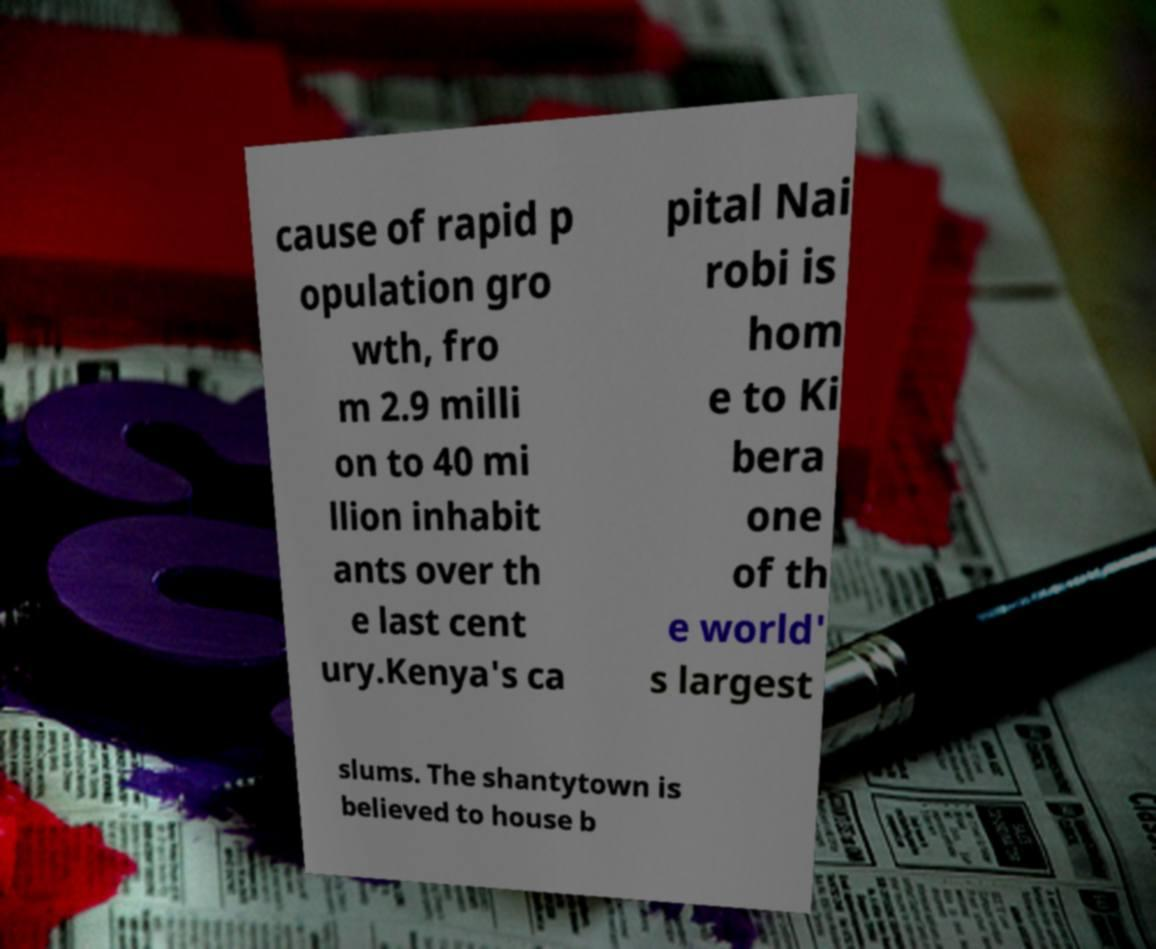For documentation purposes, I need the text within this image transcribed. Could you provide that? cause of rapid p opulation gro wth, fro m 2.9 milli on to 40 mi llion inhabit ants over th e last cent ury.Kenya's ca pital Nai robi is hom e to Ki bera one of th e world' s largest slums. The shantytown is believed to house b 